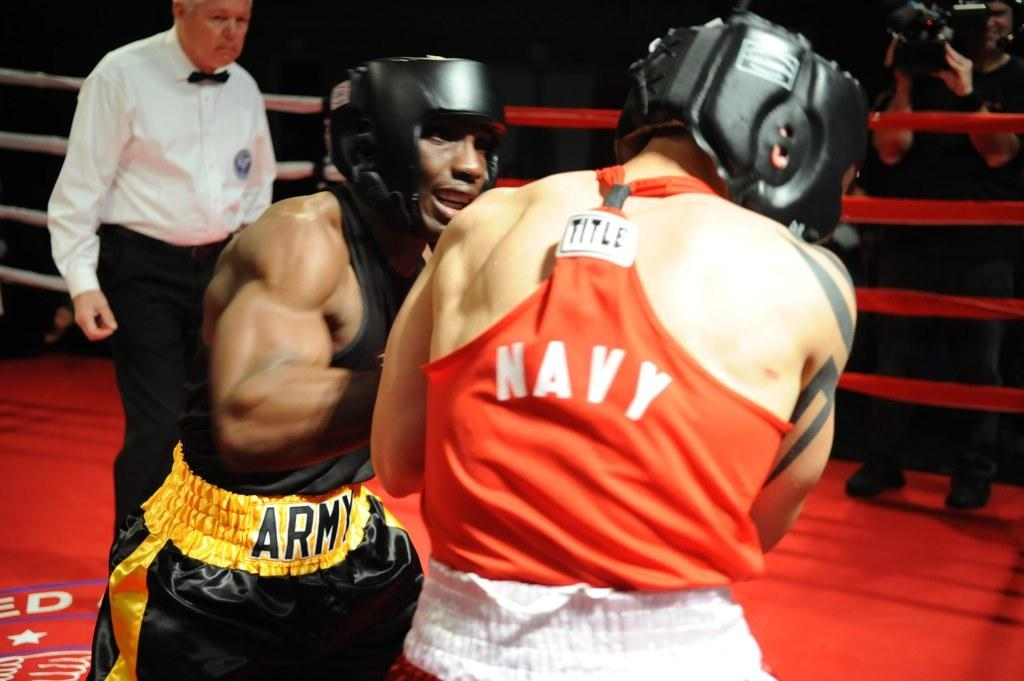<image>
Write a terse but informative summary of the picture. Two boxers in the ring both are from different branches of the military. 